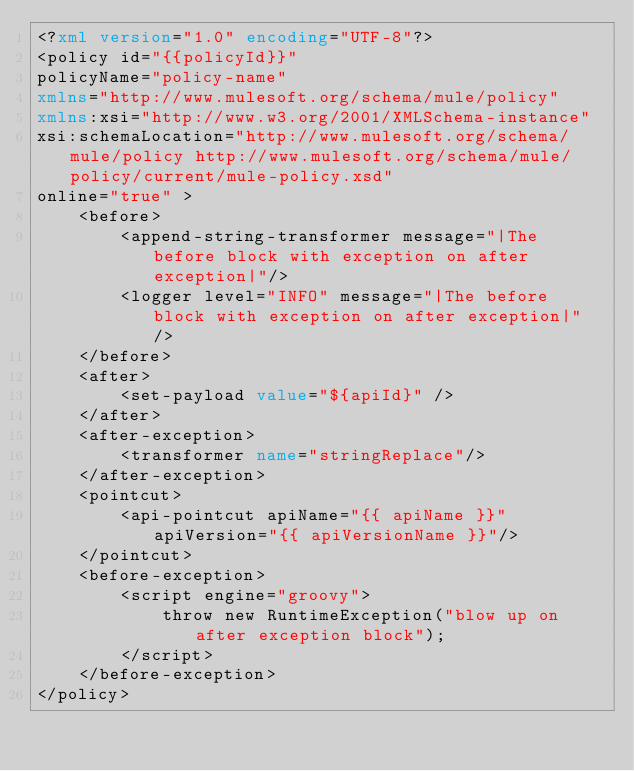<code> <loc_0><loc_0><loc_500><loc_500><_XML_><?xml version="1.0" encoding="UTF-8"?>
<policy id="{{policyId}}"
policyName="policy-name"
xmlns="http://www.mulesoft.org/schema/mule/policy"
xmlns:xsi="http://www.w3.org/2001/XMLSchema-instance"
xsi:schemaLocation="http://www.mulesoft.org/schema/mule/policy http://www.mulesoft.org/schema/mule/policy/current/mule-policy.xsd"
online="true" >
	<before>
		<append-string-transformer message="|The before block with exception on after exception|"/>
		<logger level="INFO" message="|The before block with exception on after exception|" />
	</before>
	<after>
		<set-payload value="${apiId}" />
	</after>
	<after-exception>
		<transformer name="stringReplace"/>
	</after-exception>
	<pointcut>
		<api-pointcut apiName="{{ apiName }}" apiVersion="{{ apiVersionName }}"/>
	</pointcut>
	<before-exception>
		<script engine="groovy">
			throw new RuntimeException("blow up on after exception block");
		</script>
	</before-exception>
</policy></code> 